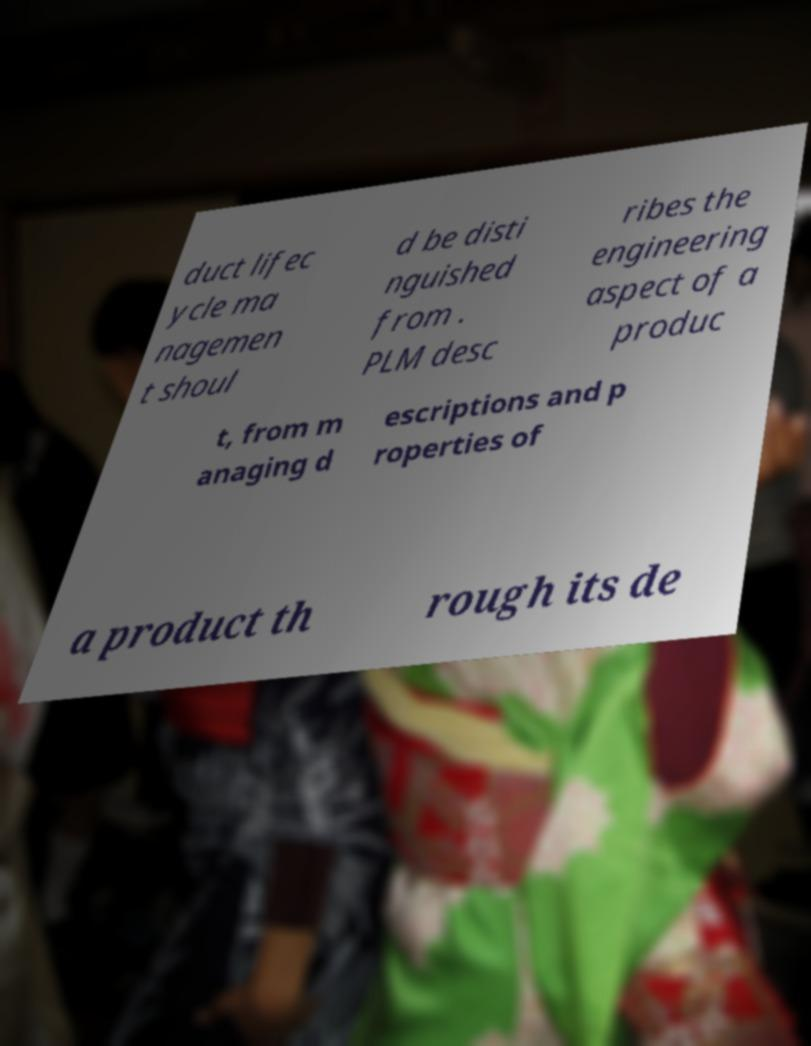Could you extract and type out the text from this image? duct lifec ycle ma nagemen t shoul d be disti nguished from . PLM desc ribes the engineering aspect of a produc t, from m anaging d escriptions and p roperties of a product th rough its de 